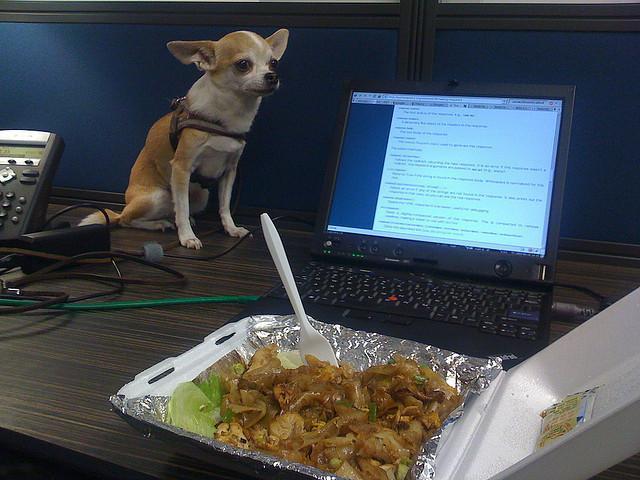How many benches are in a row?
Give a very brief answer. 0. 